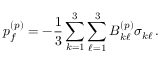<formula> <loc_0><loc_0><loc_500><loc_500>p _ { f } ^ { ( p ) } = - \frac { 1 } { 3 } \sum _ { k = 1 } ^ { 3 } \sum _ { \ell = 1 } ^ { 3 } B _ { k \ell } ^ { ( p ) } \sigma _ { k \ell } \, .</formula> 